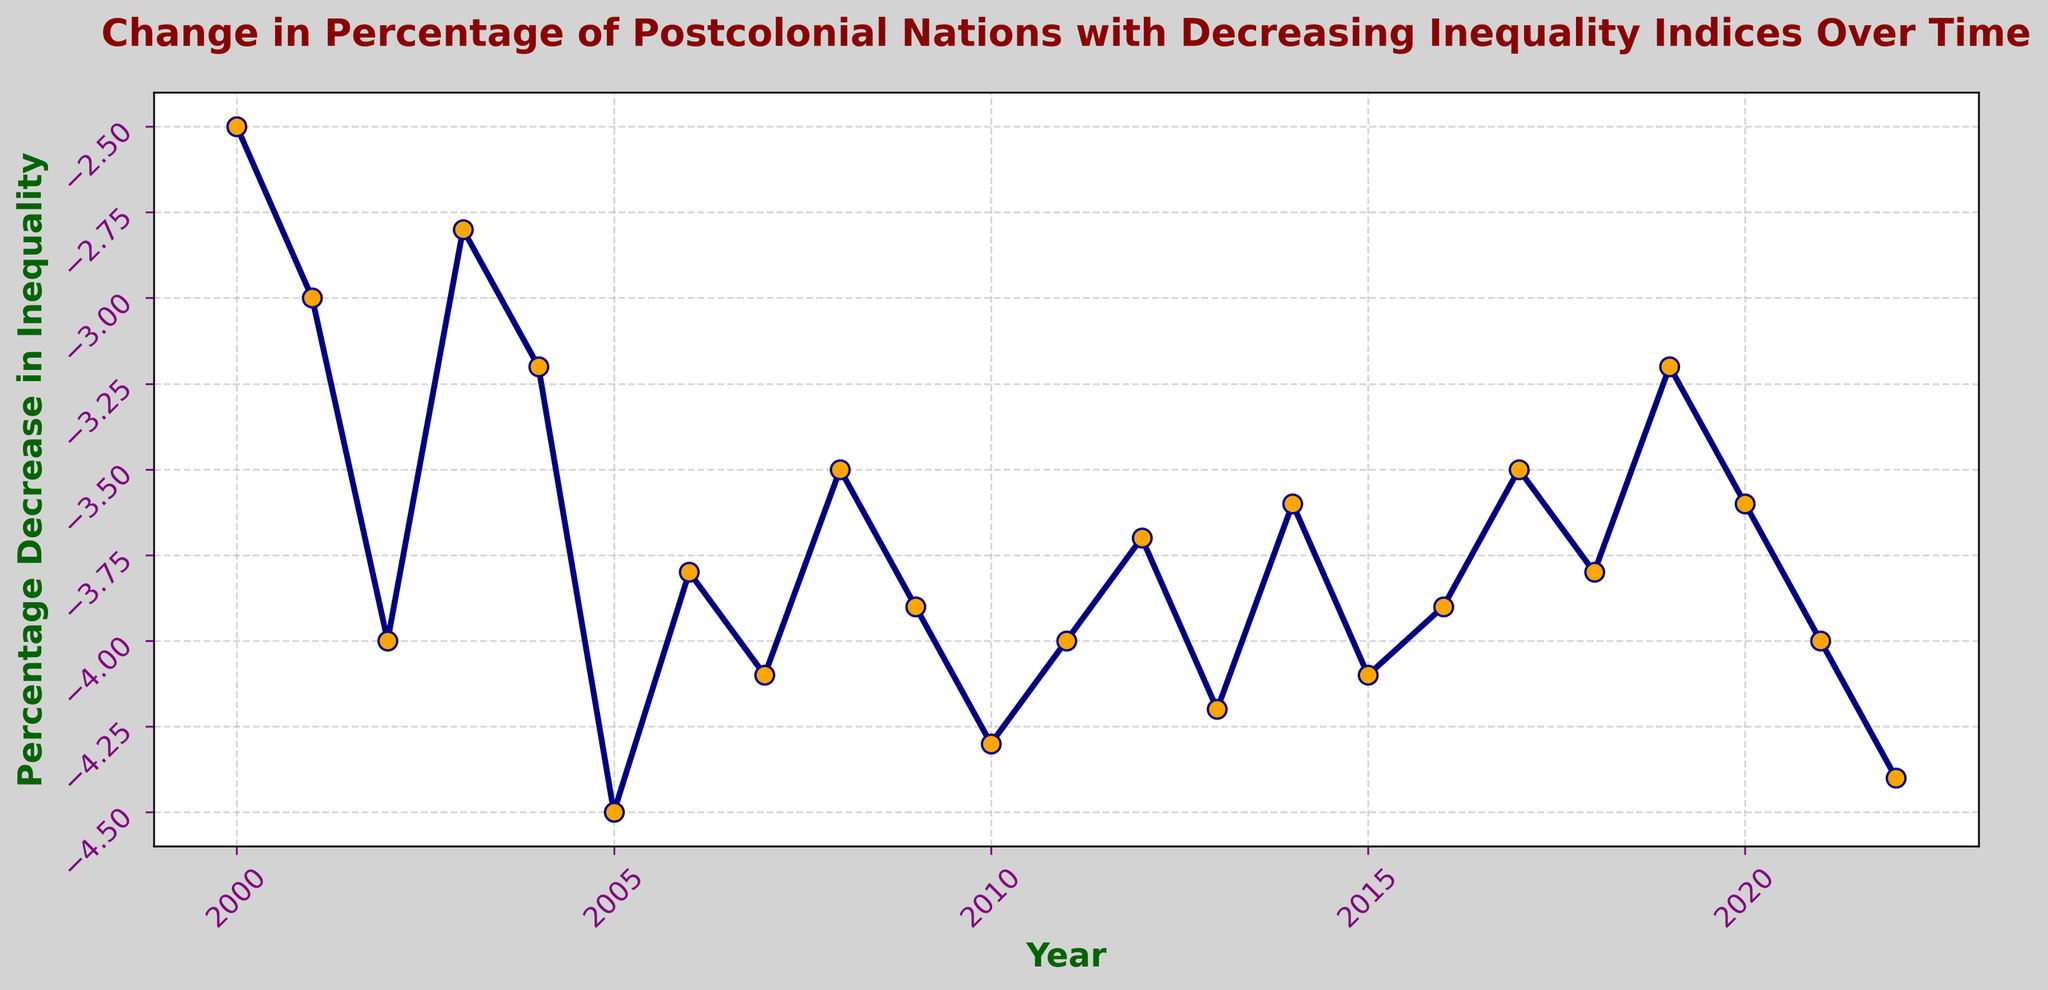What was the percentage decrease in inequality in 2001? Locate the data point for the year 2001 on the x-axis. The y-axis value corresponding to 2001 is -3.0.
Answer: -3.0 Which year had the maximum percentage decrease in inequality? Find the lowest point on the plot, indicating the highest decrease. The year at this point is 2005 with a value of -4.5.
Answer: 2005 Which year had a higher percentage decrease in inequality, 2015 or 2019? Locate the points for 2015 and 2019 on the x-axis. Compare their y-axis values; 2015 is at -4.1 and 2019 is at -3.2. Since -4.1 is lower than -3.2, the decrease in inequality was higher in 2015.
Answer: 2015 By how much did the percentage decrease in inequality change from 2000 to 2005? Subtract the value in 2000 from the value in 2005; (-4.5) - (-2.5) = -4.5 + 2.5 = -2.0.
Answer: -2.0 What is the average percentage decrease in inequality over the period 2010 to 2015? Calculate the sum of the values from 2010 to 2015 and divide by 6; (-4.3 + -4.0 + -3.7 + -4.2 + -3.6 + -4.1) / 6 = -23.9 / 6 = -3.98.
Answer: -3.98 Was the percentage decrease in inequality ever the same for any two years? Inspect the plot for repeating y-axis values. Both 2002 and 2011 show the same value of -4.0.
Answer: Yes Identify the trend in the percentage decrease in inequality from 2019 to 2022. Observe the plot from 2019 to 2022; the values change from -3.2 to -4.4, indicating a general downward (more negative) trend.
Answer: Downward trend Which year marked the beginning of an increasing trend in the percentage decrease until 2019? Look for a point where the plot changes from decreasing to increasing before 2019; post-2017 (-3.5) to 2018 (-3.8) and then decreasing trend until 2019 and so on.
Answer: 2017 